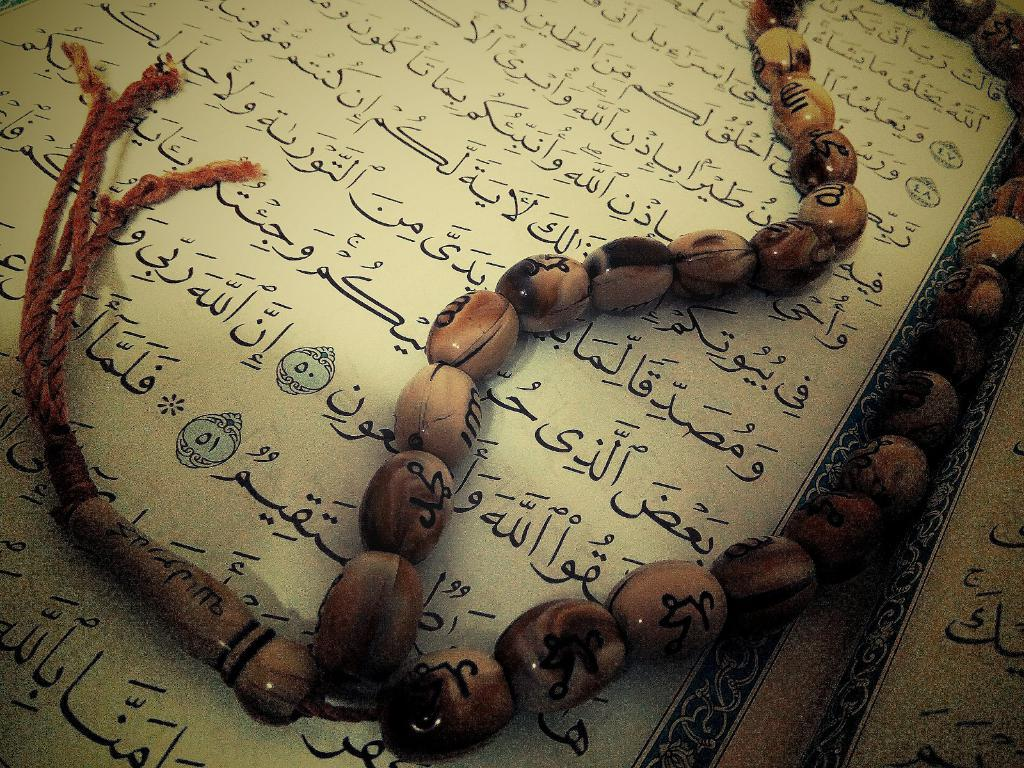What is written or depicted at the bottom of the image? There is a language script at the bottom of the image. Are there any additional elements associated with the script? Yes, there is a necklace made up of wooden beads on the script. How many bees can be seen flying around the basin in the image? There are no bees or basins present in the image. Are there any fairies visible in the image? There is no mention of fairies in the provided facts, and therefore they cannot be confirmed to be present in the image. 